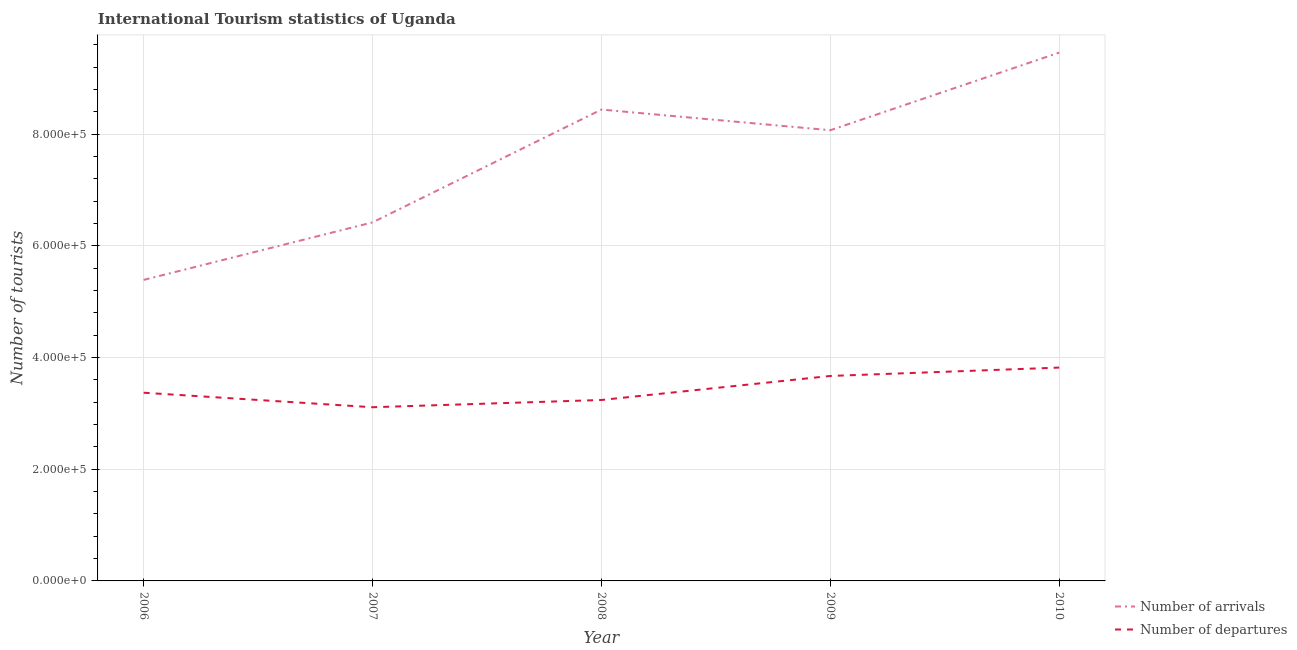How many different coloured lines are there?
Keep it short and to the point. 2. Does the line corresponding to number of tourist arrivals intersect with the line corresponding to number of tourist departures?
Offer a terse response. No. Is the number of lines equal to the number of legend labels?
Ensure brevity in your answer.  Yes. What is the number of tourist arrivals in 2008?
Ensure brevity in your answer.  8.44e+05. Across all years, what is the maximum number of tourist departures?
Give a very brief answer. 3.82e+05. Across all years, what is the minimum number of tourist arrivals?
Provide a succinct answer. 5.39e+05. In which year was the number of tourist arrivals minimum?
Your answer should be compact. 2006. What is the total number of tourist departures in the graph?
Offer a terse response. 1.72e+06. What is the difference between the number of tourist departures in 2006 and that in 2007?
Your response must be concise. 2.60e+04. What is the difference between the number of tourist arrivals in 2008 and the number of tourist departures in 2009?
Offer a very short reply. 4.77e+05. What is the average number of tourist arrivals per year?
Offer a terse response. 7.56e+05. In the year 2010, what is the difference between the number of tourist departures and number of tourist arrivals?
Your answer should be compact. -5.64e+05. In how many years, is the number of tourist arrivals greater than 840000?
Provide a short and direct response. 2. What is the ratio of the number of tourist departures in 2007 to that in 2008?
Offer a terse response. 0.96. Is the number of tourist departures in 2006 less than that in 2007?
Keep it short and to the point. No. What is the difference between the highest and the second highest number of tourist arrivals?
Keep it short and to the point. 1.02e+05. What is the difference between the highest and the lowest number of tourist arrivals?
Provide a succinct answer. 4.07e+05. In how many years, is the number of tourist departures greater than the average number of tourist departures taken over all years?
Make the answer very short. 2. Is the number of tourist departures strictly less than the number of tourist arrivals over the years?
Offer a terse response. Yes. How many lines are there?
Your answer should be very brief. 2. Are the values on the major ticks of Y-axis written in scientific E-notation?
Your answer should be compact. Yes. Where does the legend appear in the graph?
Offer a terse response. Bottom right. How many legend labels are there?
Ensure brevity in your answer.  2. How are the legend labels stacked?
Keep it short and to the point. Vertical. What is the title of the graph?
Ensure brevity in your answer.  International Tourism statistics of Uganda. Does "Education" appear as one of the legend labels in the graph?
Provide a succinct answer. No. What is the label or title of the X-axis?
Your answer should be very brief. Year. What is the label or title of the Y-axis?
Provide a succinct answer. Number of tourists. What is the Number of tourists in Number of arrivals in 2006?
Your answer should be very brief. 5.39e+05. What is the Number of tourists of Number of departures in 2006?
Offer a very short reply. 3.37e+05. What is the Number of tourists in Number of arrivals in 2007?
Offer a terse response. 6.42e+05. What is the Number of tourists of Number of departures in 2007?
Offer a very short reply. 3.11e+05. What is the Number of tourists in Number of arrivals in 2008?
Your response must be concise. 8.44e+05. What is the Number of tourists of Number of departures in 2008?
Provide a short and direct response. 3.24e+05. What is the Number of tourists of Number of arrivals in 2009?
Give a very brief answer. 8.07e+05. What is the Number of tourists in Number of departures in 2009?
Give a very brief answer. 3.67e+05. What is the Number of tourists in Number of arrivals in 2010?
Provide a succinct answer. 9.46e+05. What is the Number of tourists of Number of departures in 2010?
Make the answer very short. 3.82e+05. Across all years, what is the maximum Number of tourists in Number of arrivals?
Your response must be concise. 9.46e+05. Across all years, what is the maximum Number of tourists of Number of departures?
Ensure brevity in your answer.  3.82e+05. Across all years, what is the minimum Number of tourists of Number of arrivals?
Give a very brief answer. 5.39e+05. Across all years, what is the minimum Number of tourists of Number of departures?
Offer a terse response. 3.11e+05. What is the total Number of tourists in Number of arrivals in the graph?
Keep it short and to the point. 3.78e+06. What is the total Number of tourists of Number of departures in the graph?
Offer a terse response. 1.72e+06. What is the difference between the Number of tourists of Number of arrivals in 2006 and that in 2007?
Give a very brief answer. -1.03e+05. What is the difference between the Number of tourists of Number of departures in 2006 and that in 2007?
Provide a short and direct response. 2.60e+04. What is the difference between the Number of tourists in Number of arrivals in 2006 and that in 2008?
Offer a terse response. -3.05e+05. What is the difference between the Number of tourists of Number of departures in 2006 and that in 2008?
Give a very brief answer. 1.30e+04. What is the difference between the Number of tourists in Number of arrivals in 2006 and that in 2009?
Provide a succinct answer. -2.68e+05. What is the difference between the Number of tourists in Number of arrivals in 2006 and that in 2010?
Your answer should be very brief. -4.07e+05. What is the difference between the Number of tourists in Number of departures in 2006 and that in 2010?
Provide a succinct answer. -4.50e+04. What is the difference between the Number of tourists of Number of arrivals in 2007 and that in 2008?
Provide a succinct answer. -2.02e+05. What is the difference between the Number of tourists of Number of departures in 2007 and that in 2008?
Provide a succinct answer. -1.30e+04. What is the difference between the Number of tourists in Number of arrivals in 2007 and that in 2009?
Your response must be concise. -1.65e+05. What is the difference between the Number of tourists of Number of departures in 2007 and that in 2009?
Offer a very short reply. -5.60e+04. What is the difference between the Number of tourists of Number of arrivals in 2007 and that in 2010?
Provide a succinct answer. -3.04e+05. What is the difference between the Number of tourists of Number of departures in 2007 and that in 2010?
Give a very brief answer. -7.10e+04. What is the difference between the Number of tourists of Number of arrivals in 2008 and that in 2009?
Make the answer very short. 3.70e+04. What is the difference between the Number of tourists of Number of departures in 2008 and that in 2009?
Offer a terse response. -4.30e+04. What is the difference between the Number of tourists of Number of arrivals in 2008 and that in 2010?
Keep it short and to the point. -1.02e+05. What is the difference between the Number of tourists of Number of departures in 2008 and that in 2010?
Provide a short and direct response. -5.80e+04. What is the difference between the Number of tourists in Number of arrivals in 2009 and that in 2010?
Provide a succinct answer. -1.39e+05. What is the difference between the Number of tourists of Number of departures in 2009 and that in 2010?
Provide a succinct answer. -1.50e+04. What is the difference between the Number of tourists in Number of arrivals in 2006 and the Number of tourists in Number of departures in 2007?
Your response must be concise. 2.28e+05. What is the difference between the Number of tourists in Number of arrivals in 2006 and the Number of tourists in Number of departures in 2008?
Offer a terse response. 2.15e+05. What is the difference between the Number of tourists in Number of arrivals in 2006 and the Number of tourists in Number of departures in 2009?
Ensure brevity in your answer.  1.72e+05. What is the difference between the Number of tourists in Number of arrivals in 2006 and the Number of tourists in Number of departures in 2010?
Offer a very short reply. 1.57e+05. What is the difference between the Number of tourists of Number of arrivals in 2007 and the Number of tourists of Number of departures in 2008?
Your response must be concise. 3.18e+05. What is the difference between the Number of tourists of Number of arrivals in 2007 and the Number of tourists of Number of departures in 2009?
Give a very brief answer. 2.75e+05. What is the difference between the Number of tourists in Number of arrivals in 2007 and the Number of tourists in Number of departures in 2010?
Your response must be concise. 2.60e+05. What is the difference between the Number of tourists of Number of arrivals in 2008 and the Number of tourists of Number of departures in 2009?
Your response must be concise. 4.77e+05. What is the difference between the Number of tourists of Number of arrivals in 2008 and the Number of tourists of Number of departures in 2010?
Make the answer very short. 4.62e+05. What is the difference between the Number of tourists of Number of arrivals in 2009 and the Number of tourists of Number of departures in 2010?
Keep it short and to the point. 4.25e+05. What is the average Number of tourists in Number of arrivals per year?
Give a very brief answer. 7.56e+05. What is the average Number of tourists of Number of departures per year?
Keep it short and to the point. 3.44e+05. In the year 2006, what is the difference between the Number of tourists in Number of arrivals and Number of tourists in Number of departures?
Ensure brevity in your answer.  2.02e+05. In the year 2007, what is the difference between the Number of tourists in Number of arrivals and Number of tourists in Number of departures?
Your answer should be compact. 3.31e+05. In the year 2008, what is the difference between the Number of tourists of Number of arrivals and Number of tourists of Number of departures?
Provide a succinct answer. 5.20e+05. In the year 2009, what is the difference between the Number of tourists in Number of arrivals and Number of tourists in Number of departures?
Offer a very short reply. 4.40e+05. In the year 2010, what is the difference between the Number of tourists in Number of arrivals and Number of tourists in Number of departures?
Your answer should be compact. 5.64e+05. What is the ratio of the Number of tourists of Number of arrivals in 2006 to that in 2007?
Provide a succinct answer. 0.84. What is the ratio of the Number of tourists in Number of departures in 2006 to that in 2007?
Your response must be concise. 1.08. What is the ratio of the Number of tourists of Number of arrivals in 2006 to that in 2008?
Keep it short and to the point. 0.64. What is the ratio of the Number of tourists of Number of departures in 2006 to that in 2008?
Make the answer very short. 1.04. What is the ratio of the Number of tourists of Number of arrivals in 2006 to that in 2009?
Provide a succinct answer. 0.67. What is the ratio of the Number of tourists of Number of departures in 2006 to that in 2009?
Offer a very short reply. 0.92. What is the ratio of the Number of tourists of Number of arrivals in 2006 to that in 2010?
Provide a succinct answer. 0.57. What is the ratio of the Number of tourists in Number of departures in 2006 to that in 2010?
Provide a succinct answer. 0.88. What is the ratio of the Number of tourists of Number of arrivals in 2007 to that in 2008?
Offer a very short reply. 0.76. What is the ratio of the Number of tourists of Number of departures in 2007 to that in 2008?
Offer a very short reply. 0.96. What is the ratio of the Number of tourists of Number of arrivals in 2007 to that in 2009?
Provide a short and direct response. 0.8. What is the ratio of the Number of tourists in Number of departures in 2007 to that in 2009?
Your answer should be compact. 0.85. What is the ratio of the Number of tourists of Number of arrivals in 2007 to that in 2010?
Your response must be concise. 0.68. What is the ratio of the Number of tourists of Number of departures in 2007 to that in 2010?
Provide a short and direct response. 0.81. What is the ratio of the Number of tourists of Number of arrivals in 2008 to that in 2009?
Offer a very short reply. 1.05. What is the ratio of the Number of tourists in Number of departures in 2008 to that in 2009?
Provide a succinct answer. 0.88. What is the ratio of the Number of tourists in Number of arrivals in 2008 to that in 2010?
Offer a very short reply. 0.89. What is the ratio of the Number of tourists of Number of departures in 2008 to that in 2010?
Your answer should be compact. 0.85. What is the ratio of the Number of tourists of Number of arrivals in 2009 to that in 2010?
Offer a very short reply. 0.85. What is the ratio of the Number of tourists in Number of departures in 2009 to that in 2010?
Your response must be concise. 0.96. What is the difference between the highest and the second highest Number of tourists of Number of arrivals?
Offer a terse response. 1.02e+05. What is the difference between the highest and the second highest Number of tourists in Number of departures?
Ensure brevity in your answer.  1.50e+04. What is the difference between the highest and the lowest Number of tourists in Number of arrivals?
Keep it short and to the point. 4.07e+05. What is the difference between the highest and the lowest Number of tourists of Number of departures?
Offer a very short reply. 7.10e+04. 